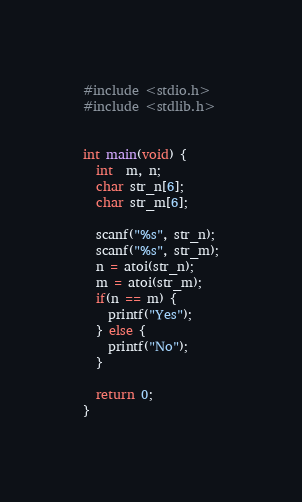Convert code to text. <code><loc_0><loc_0><loc_500><loc_500><_C_>#include <stdio.h>
#include <stdlib.h>


int main(void) {
  int  m, n;
  char str_n[6];
  char str_m[6];
  
  scanf("%s", str_n);
  scanf("%s", str_m);
  n = atoi(str_n);
  m = atoi(str_m);
  if(n == m) {
    printf("Yes");
  } else {
    printf("No");
  }
  
  return 0;
}</code> 